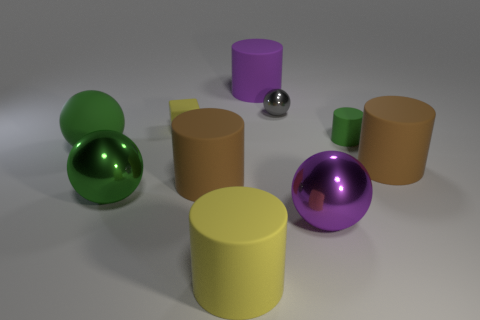How would you compare the two cylindrical objects in terms of their height? The yellow cylindrical object on the left is taller than the brown cylinder to its immediate right. The yellow cylinder's height accentuates its presence among the collection of shapes. 